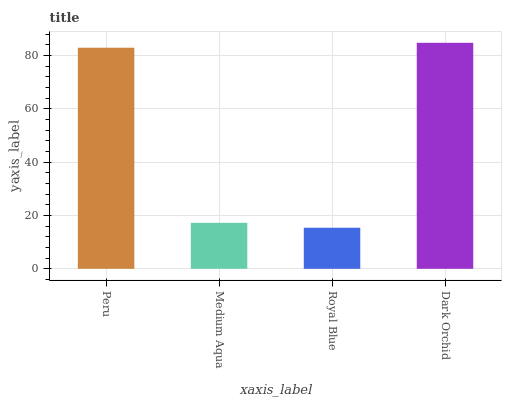Is Dark Orchid the maximum?
Answer yes or no. Yes. Is Medium Aqua the minimum?
Answer yes or no. No. Is Medium Aqua the maximum?
Answer yes or no. No. Is Peru greater than Medium Aqua?
Answer yes or no. Yes. Is Medium Aqua less than Peru?
Answer yes or no. Yes. Is Medium Aqua greater than Peru?
Answer yes or no. No. Is Peru less than Medium Aqua?
Answer yes or no. No. Is Peru the high median?
Answer yes or no. Yes. Is Medium Aqua the low median?
Answer yes or no. Yes. Is Royal Blue the high median?
Answer yes or no. No. Is Royal Blue the low median?
Answer yes or no. No. 